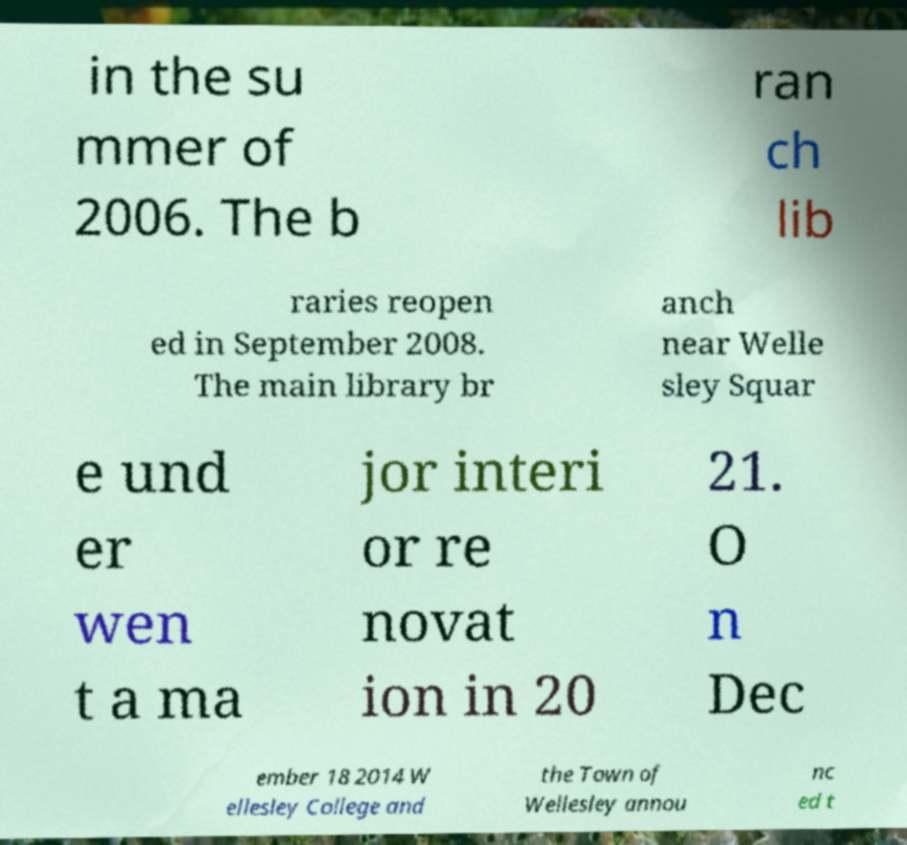Please read and relay the text visible in this image. What does it say? in the su mmer of 2006. The b ran ch lib raries reopen ed in September 2008. The main library br anch near Welle sley Squar e und er wen t a ma jor interi or re novat ion in 20 21. O n Dec ember 18 2014 W ellesley College and the Town of Wellesley annou nc ed t 